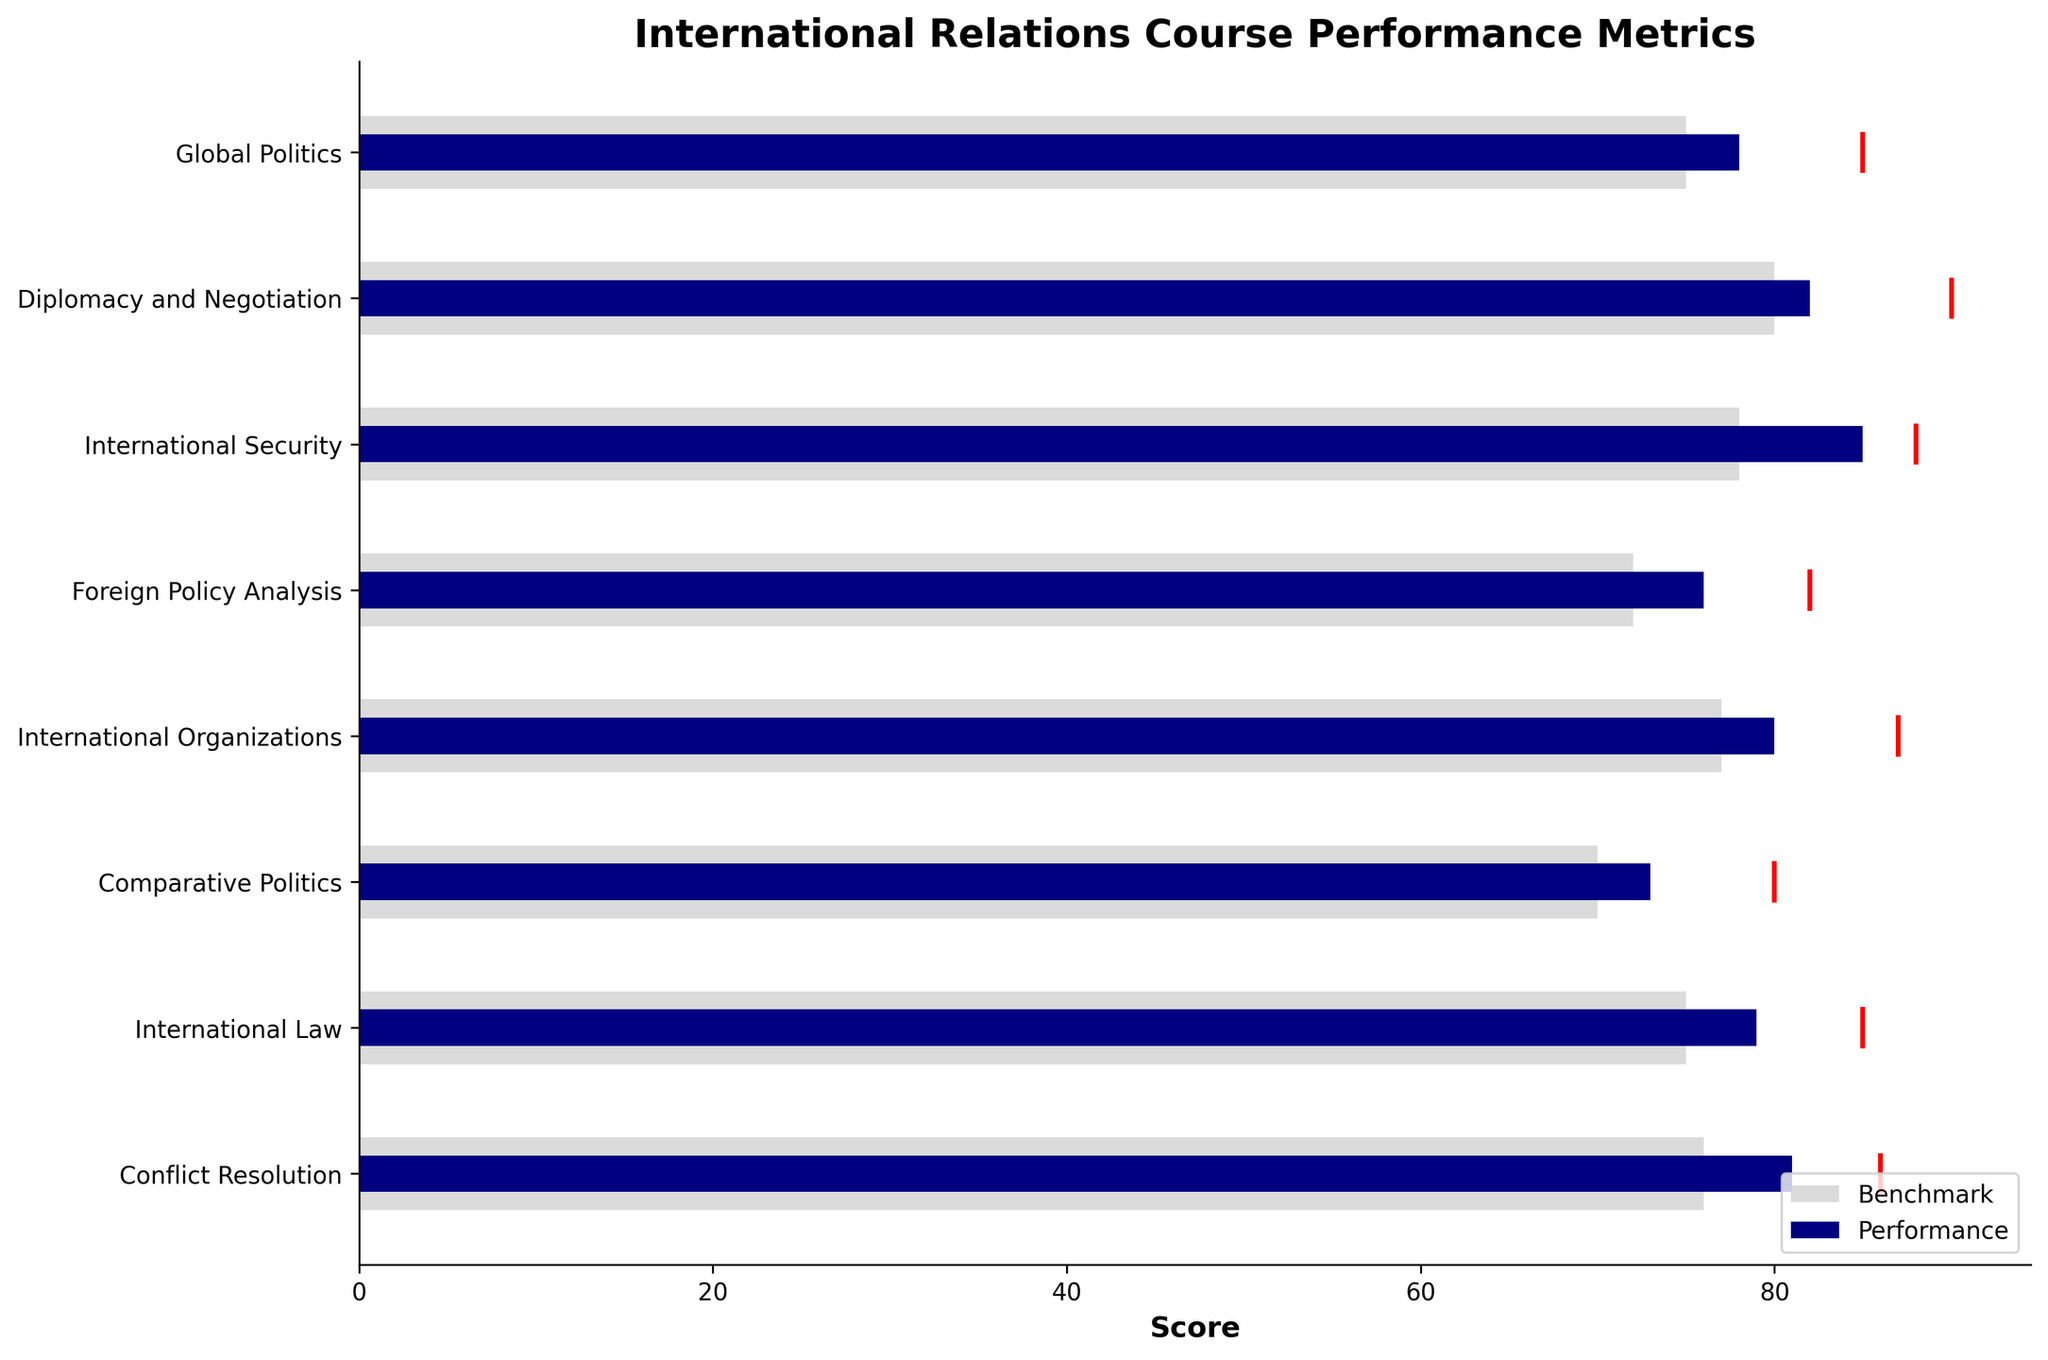What's the title of the figure? The title of the figure is a direct text element located at the top of the graph. It gives an overview of what the figure represents. The title as seen in the figure is "International Relations Course Performance Metrics".
Answer: International Relations Course Performance Metrics What are the colors used to represent benchmarks and performances? The figure uses different colors to easily distinguish between benchmarks and performances. Benchmarks are represented in light grey, and performances are shown in navy.
Answer: Light grey for benchmarks and navy for performances What is the performance score for the course "International Security"? By locating the "International Security" label on the y-axis and following the corresponding horizontal bar, we find that the performance score is shown as 85.
Answer: 85 Which course has the highest benchmark score? To determine which course has the highest benchmark score, we compare the benchmark values for each course. "Diplomacy and Negotiation" has the highest benchmark score at 80.
Answer: Diplomacy and Negotiation How many courses have a target score above 85? By inspecting the red target lines for each course, we observe that the courses "Global Politics", "Diplomacy and Negotiation", "International Security", "International Organizations", and "Conflict Resolution" all have target scores above 85. There are 5 such courses.
Answer: 5 What is the difference between the performance and benchmark scores for "Foreign Policy Analysis"? To find the difference, subtract the benchmark score from the performance score for the course "Foreign Policy Analysis". The performance score is 76 and the benchmark score is 72. So, the difference is 76 - 72 = 4.
Answer: 4 Which two courses have the closest performance scores? By visually comparing the lengths of the navy bars for each course, "Diplomacy and Negotiation" and "Conflict Resolution" have close performance scores of 82 and 81, respectively.
Answer: Diplomacy and Negotiation, Conflict Resolution Is the performance for "Comparative Politics" above or below the target score? By locating the target red line for "Comparative Politics" and comparing it with the navy bar, it is seen that the performance score (73) is below the target score (80).
Answer: Below What is the average benchmark score for all courses? Sum all benchmark scores: 75 + 80 + 78 + 72 + 77 + 70 + 75 + 76 = 603. Divide the sum by the number of courses (8), yielding an average benchmark score of 603 / 8 = 75.375.
Answer: 75.375 For the course "Global Politics", how far below the target is the current performance? The target score for "Global Politics" is 85, and the performance score is 78. The difference is calculated as 85 - 78 = 7.
Answer: 7 